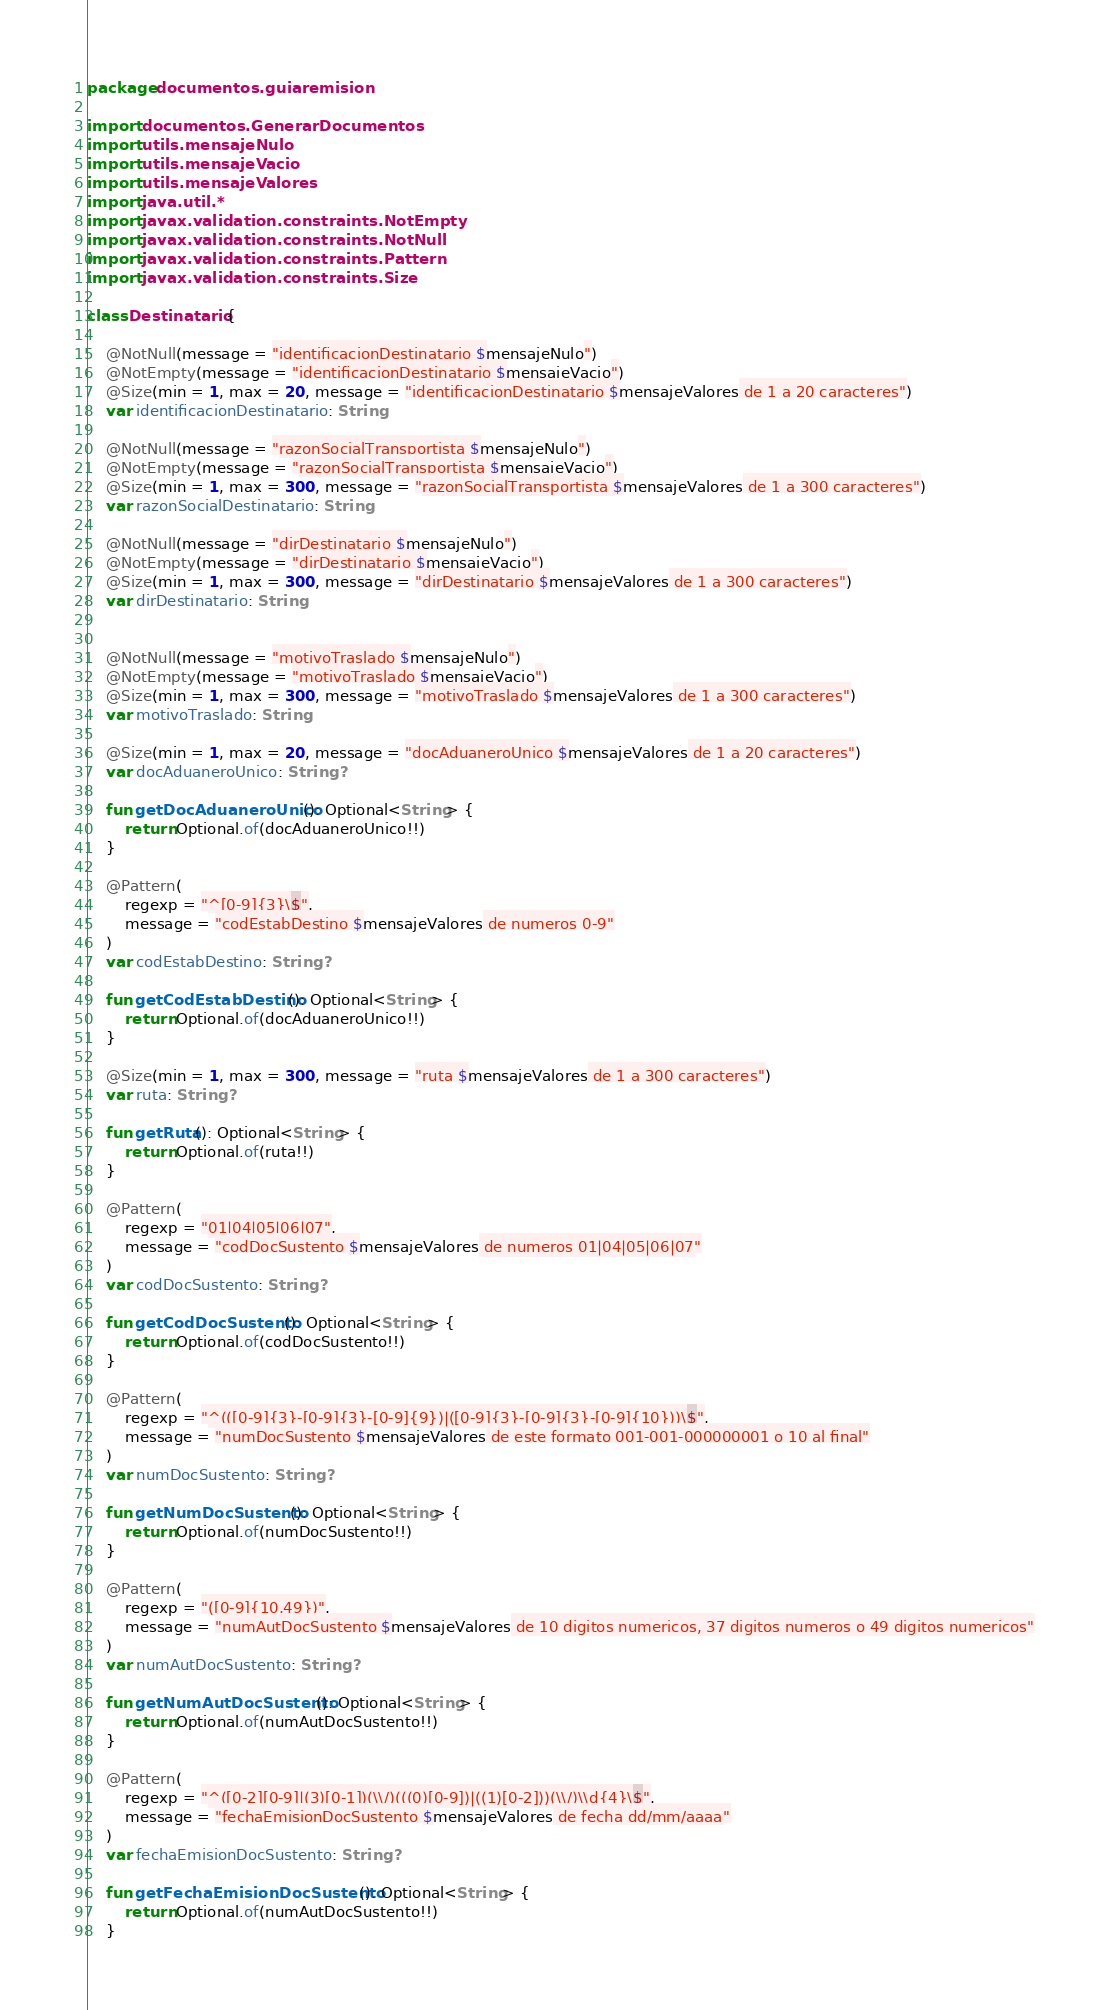Convert code to text. <code><loc_0><loc_0><loc_500><loc_500><_Kotlin_>package documentos.guiaremision

import documentos.GenerarDocumentos
import utils.mensajeNulo
import utils.mensajeVacio
import utils.mensajeValores
import java.util.*
import javax.validation.constraints.NotEmpty
import javax.validation.constraints.NotNull
import javax.validation.constraints.Pattern
import javax.validation.constraints.Size

class Destinatario {

    @NotNull(message = "identificacionDestinatario $mensajeNulo")
    @NotEmpty(message = "identificacionDestinatario $mensajeVacio")
    @Size(min = 1, max = 20, message = "identificacionDestinatario $mensajeValores de 1 a 20 caracteres")
    var identificacionDestinatario: String

    @NotNull(message = "razonSocialTransportista $mensajeNulo")
    @NotEmpty(message = "razonSocialTransportista $mensajeVacio")
    @Size(min = 1, max = 300, message = "razonSocialTransportista $mensajeValores de 1 a 300 caracteres")
    var razonSocialDestinatario: String

    @NotNull(message = "dirDestinatario $mensajeNulo")
    @NotEmpty(message = "dirDestinatario $mensajeVacio")
    @Size(min = 1, max = 300, message = "dirDestinatario $mensajeValores de 1 a 300 caracteres")
    var dirDestinatario: String


    @NotNull(message = "motivoTraslado $mensajeNulo")
    @NotEmpty(message = "motivoTraslado $mensajeVacio")
    @Size(min = 1, max = 300, message = "motivoTraslado $mensajeValores de 1 a 300 caracteres")
    var motivoTraslado: String

    @Size(min = 1, max = 20, message = "docAduaneroUnico $mensajeValores de 1 a 20 caracteres")
    var docAduaneroUnico: String?

    fun getDocAduaneroUnico(): Optional<String> {
        return Optional.of(docAduaneroUnico!!)
    }

    @Pattern(
        regexp = "^[0-9]{3}\$",
        message = "codEstabDestino $mensajeValores de numeros 0-9"
    )
    var codEstabDestino: String?

    fun getCodEstabDestino(): Optional<String> {
        return Optional.of(docAduaneroUnico!!)
    }

    @Size(min = 1, max = 300, message = "ruta $mensajeValores de 1 a 300 caracteres")
    var ruta: String?

    fun getRuta(): Optional<String> {
        return Optional.of(ruta!!)
    }

    @Pattern(
        regexp = "01|04|05|06|07",
        message = "codDocSustento $mensajeValores de numeros 01|04|05|06|07"
    )
    var codDocSustento: String?

    fun getCodDocSustento(): Optional<String> {
        return Optional.of(codDocSustento!!)
    }

    @Pattern(
        regexp = "^(([0-9]{3}-[0-9]{3}-[0-9]{9})|([0-9]{3}-[0-9]{3}-[0-9]{10}))\$",
        message = "numDocSustento $mensajeValores de este formato 001-001-000000001 o 10 al final"
    )
    var numDocSustento: String?

    fun getNumDocSustento(): Optional<String> {
        return Optional.of(numDocSustento!!)
    }

    @Pattern(
        regexp = "([0-9]{10,49})",
        message = "numAutDocSustento $mensajeValores de 10 digitos numericos, 37 digitos numeros o 49 digitos numericos"
    )
    var numAutDocSustento: String?

    fun getNumAutDocSustento(): Optional<String> {
        return Optional.of(numAutDocSustento!!)
    }

    @Pattern(
        regexp = "^([0-2][0-9]|(3)[0-1])(\\/)(((0)[0-9])|((1)[0-2]))(\\/)\\d{4}\$",
        message = "fechaEmisionDocSustento $mensajeValores de fecha dd/mm/aaaa"
    )
    var fechaEmisionDocSustento: String?

    fun getFechaEmisionDocSustento(): Optional<String> {
        return Optional.of(numAutDocSustento!!)
    }
</code> 